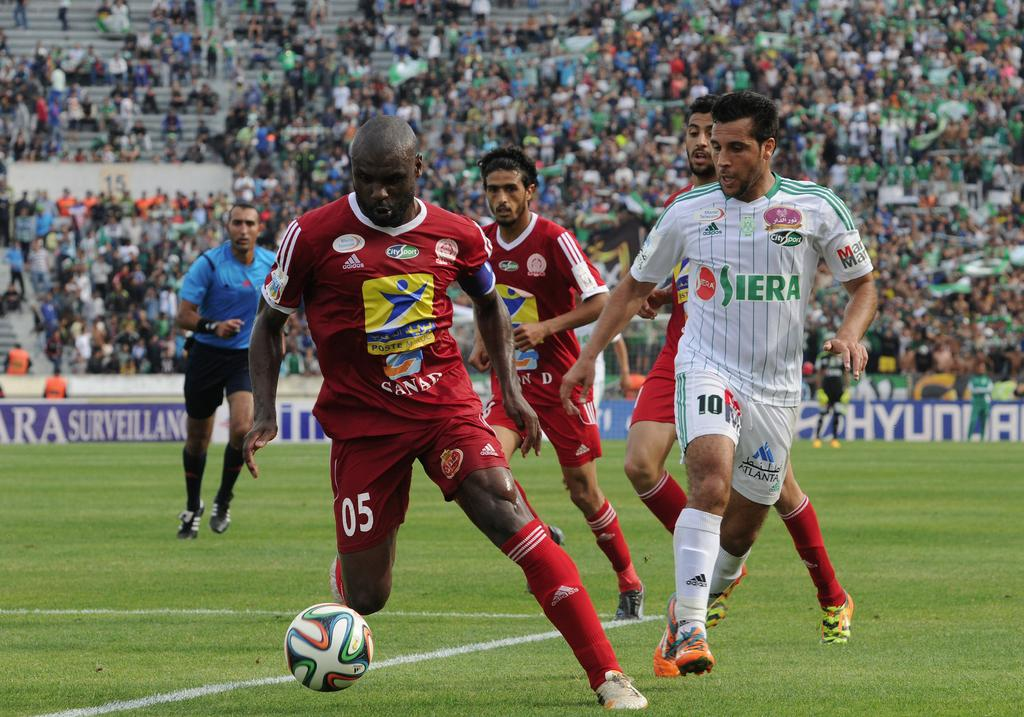Provide a one-sentence caption for the provided image. The red-kitted 05 player is in full charge of the football at his soccer game. 